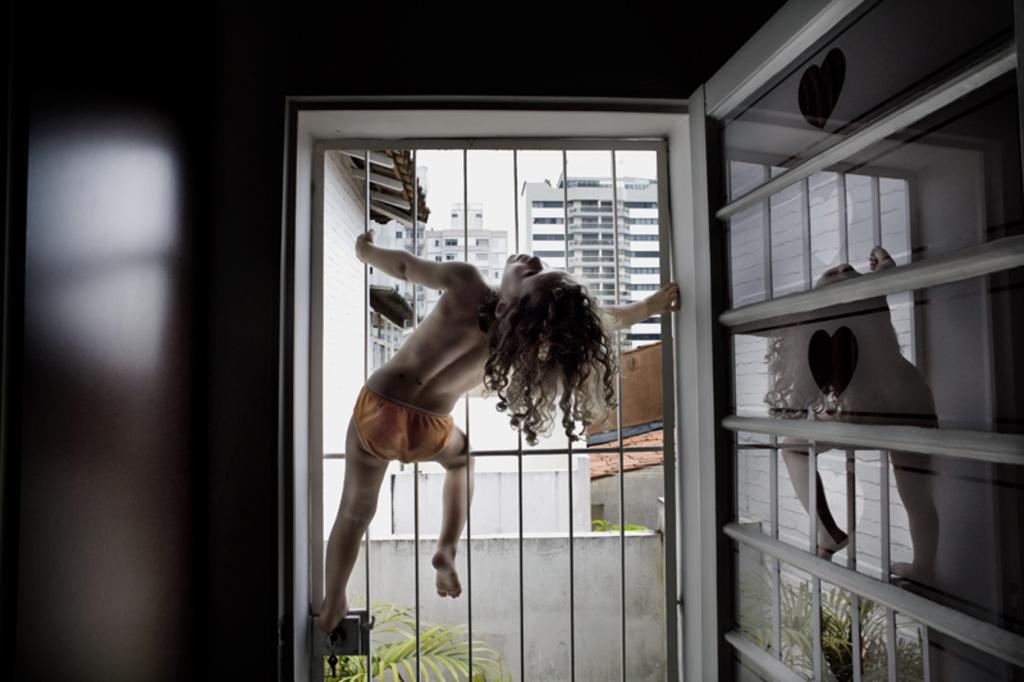How would you summarize this image in a sentence or two? In this picture, we can see a child climbing the iron gate, and we can see the wall, and we can see the reflection of that child and gate on the glass which is attached to the wall, we can see plants, buildings and the sky. 